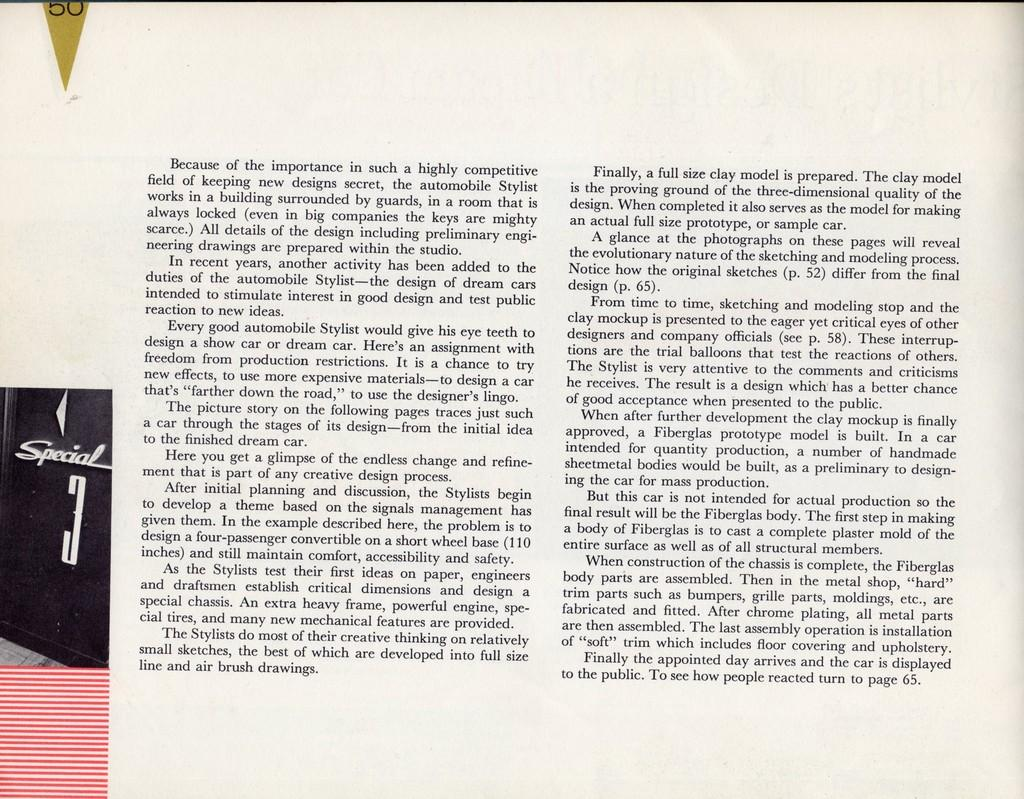<image>
Share a concise interpretation of the image provided. A page that starts with the word "Because" has black text on it. 